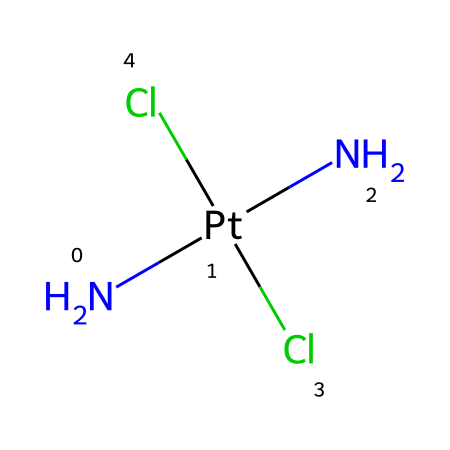What is the central metal atom in this compound? In the provided SMILES representation, 'Pt' indicates that platinum is the central metal atom connected to surrounding ligands.
Answer: platinum How many chlorine atoms are present in this molecule? The 'Cl' symbols in the SMILES show there are two chlorine atoms bonded to the platinum.
Answer: two What type of isomerism does this compound exhibit? The geometric arrangement of the ligands around the platinum atom (cis and trans) indicates that this compound exhibits geometric isomerism.
Answer: geometric isomerism What effect does the cis isomer have on therapeutic efficacy compared to the trans isomer? The cis form of the compound typically has a higher therapeutic efficacy in cancer treatment due to more effective binding to DNA, which prevents cancer cell proliferation.
Answer: higher efficacy Which isomer of platinum complex is more commonly used in cancer therapy? The cis isomer of cisplatin is commonly used in cancer therapy due to its effectiveness in cross-linking DNA.
Answer: cisplatin How many nitrogen atoms are bonded to the central metal in this compound? The 'N' symbols in the SMILES indicate that there are two nitrogen atoms bonded to the platinum metal in this compound.
Answer: two What do the ligands in the structure signify regarding the chemical reactivity? The specific ligands, including chlorides and amines, indicate that this compound can interact with biological targets in specific ways, influencing its reactivity and therapeutic action.
Answer: specific reactivity 